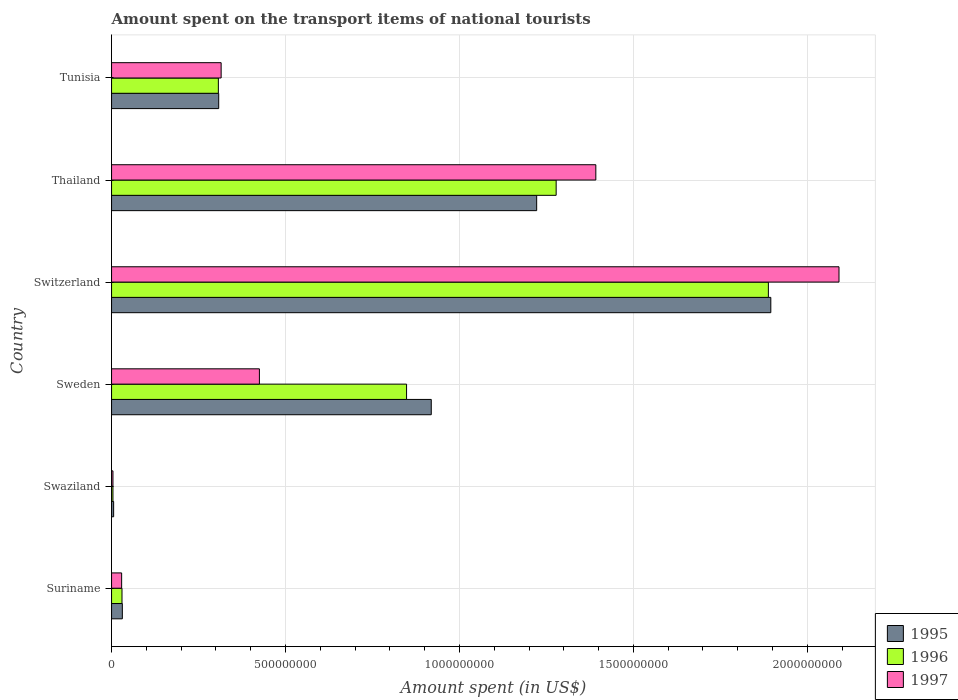How many different coloured bars are there?
Ensure brevity in your answer.  3. How many groups of bars are there?
Ensure brevity in your answer.  6. Are the number of bars per tick equal to the number of legend labels?
Offer a terse response. Yes. How many bars are there on the 2nd tick from the bottom?
Ensure brevity in your answer.  3. What is the amount spent on the transport items of national tourists in 1996 in Tunisia?
Make the answer very short. 3.07e+08. Across all countries, what is the maximum amount spent on the transport items of national tourists in 1996?
Provide a short and direct response. 1.89e+09. Across all countries, what is the minimum amount spent on the transport items of national tourists in 1995?
Your answer should be very brief. 6.00e+06. In which country was the amount spent on the transport items of national tourists in 1996 maximum?
Keep it short and to the point. Switzerland. In which country was the amount spent on the transport items of national tourists in 1995 minimum?
Your answer should be very brief. Swaziland. What is the total amount spent on the transport items of national tourists in 1996 in the graph?
Make the answer very short. 4.36e+09. What is the difference between the amount spent on the transport items of national tourists in 1996 in Switzerland and that in Tunisia?
Provide a succinct answer. 1.58e+09. What is the difference between the amount spent on the transport items of national tourists in 1996 in Tunisia and the amount spent on the transport items of national tourists in 1997 in Switzerland?
Offer a very short reply. -1.78e+09. What is the average amount spent on the transport items of national tourists in 1995 per country?
Offer a terse response. 7.30e+08. What is the difference between the amount spent on the transport items of national tourists in 1997 and amount spent on the transport items of national tourists in 1996 in Suriname?
Provide a short and direct response. -1.00e+06. What is the ratio of the amount spent on the transport items of national tourists in 1997 in Switzerland to that in Thailand?
Make the answer very short. 1.5. Is the amount spent on the transport items of national tourists in 1997 in Thailand less than that in Tunisia?
Provide a short and direct response. No. What is the difference between the highest and the second highest amount spent on the transport items of national tourists in 1997?
Provide a short and direct response. 6.99e+08. What is the difference between the highest and the lowest amount spent on the transport items of national tourists in 1995?
Provide a succinct answer. 1.89e+09. Is the sum of the amount spent on the transport items of national tourists in 1996 in Switzerland and Tunisia greater than the maximum amount spent on the transport items of national tourists in 1995 across all countries?
Your answer should be compact. Yes. What does the 3rd bar from the top in Switzerland represents?
Ensure brevity in your answer.  1995. Is it the case that in every country, the sum of the amount spent on the transport items of national tourists in 1995 and amount spent on the transport items of national tourists in 1997 is greater than the amount spent on the transport items of national tourists in 1996?
Provide a succinct answer. Yes. Are all the bars in the graph horizontal?
Give a very brief answer. Yes. How many countries are there in the graph?
Make the answer very short. 6. What is the difference between two consecutive major ticks on the X-axis?
Keep it short and to the point. 5.00e+08. Where does the legend appear in the graph?
Offer a very short reply. Bottom right. What is the title of the graph?
Your answer should be very brief. Amount spent on the transport items of national tourists. What is the label or title of the X-axis?
Your response must be concise. Amount spent (in US$). What is the label or title of the Y-axis?
Your answer should be compact. Country. What is the Amount spent (in US$) in 1995 in Suriname?
Offer a terse response. 3.10e+07. What is the Amount spent (in US$) in 1996 in Suriname?
Provide a succinct answer. 3.00e+07. What is the Amount spent (in US$) of 1997 in Suriname?
Your response must be concise. 2.90e+07. What is the Amount spent (in US$) of 1996 in Swaziland?
Make the answer very short. 4.00e+06. What is the Amount spent (in US$) in 1995 in Sweden?
Provide a succinct answer. 9.19e+08. What is the Amount spent (in US$) of 1996 in Sweden?
Offer a very short reply. 8.48e+08. What is the Amount spent (in US$) in 1997 in Sweden?
Make the answer very short. 4.25e+08. What is the Amount spent (in US$) of 1995 in Switzerland?
Your answer should be very brief. 1.90e+09. What is the Amount spent (in US$) in 1996 in Switzerland?
Offer a terse response. 1.89e+09. What is the Amount spent (in US$) of 1997 in Switzerland?
Ensure brevity in your answer.  2.09e+09. What is the Amount spent (in US$) of 1995 in Thailand?
Your answer should be very brief. 1.22e+09. What is the Amount spent (in US$) of 1996 in Thailand?
Keep it short and to the point. 1.28e+09. What is the Amount spent (in US$) in 1997 in Thailand?
Offer a very short reply. 1.39e+09. What is the Amount spent (in US$) in 1995 in Tunisia?
Your answer should be compact. 3.08e+08. What is the Amount spent (in US$) in 1996 in Tunisia?
Provide a short and direct response. 3.07e+08. What is the Amount spent (in US$) in 1997 in Tunisia?
Give a very brief answer. 3.15e+08. Across all countries, what is the maximum Amount spent (in US$) of 1995?
Your answer should be very brief. 1.90e+09. Across all countries, what is the maximum Amount spent (in US$) in 1996?
Your response must be concise. 1.89e+09. Across all countries, what is the maximum Amount spent (in US$) in 1997?
Your answer should be very brief. 2.09e+09. Across all countries, what is the minimum Amount spent (in US$) of 1997?
Provide a succinct answer. 4.00e+06. What is the total Amount spent (in US$) in 1995 in the graph?
Offer a very short reply. 4.38e+09. What is the total Amount spent (in US$) of 1996 in the graph?
Your answer should be compact. 4.36e+09. What is the total Amount spent (in US$) in 1997 in the graph?
Your response must be concise. 4.26e+09. What is the difference between the Amount spent (in US$) in 1995 in Suriname and that in Swaziland?
Ensure brevity in your answer.  2.50e+07. What is the difference between the Amount spent (in US$) of 1996 in Suriname and that in Swaziland?
Your response must be concise. 2.60e+07. What is the difference between the Amount spent (in US$) in 1997 in Suriname and that in Swaziland?
Your response must be concise. 2.50e+07. What is the difference between the Amount spent (in US$) in 1995 in Suriname and that in Sweden?
Provide a succinct answer. -8.88e+08. What is the difference between the Amount spent (in US$) of 1996 in Suriname and that in Sweden?
Make the answer very short. -8.18e+08. What is the difference between the Amount spent (in US$) in 1997 in Suriname and that in Sweden?
Offer a very short reply. -3.96e+08. What is the difference between the Amount spent (in US$) of 1995 in Suriname and that in Switzerland?
Ensure brevity in your answer.  -1.86e+09. What is the difference between the Amount spent (in US$) in 1996 in Suriname and that in Switzerland?
Offer a very short reply. -1.86e+09. What is the difference between the Amount spent (in US$) of 1997 in Suriname and that in Switzerland?
Ensure brevity in your answer.  -2.06e+09. What is the difference between the Amount spent (in US$) in 1995 in Suriname and that in Thailand?
Provide a short and direct response. -1.19e+09. What is the difference between the Amount spent (in US$) in 1996 in Suriname and that in Thailand?
Ensure brevity in your answer.  -1.25e+09. What is the difference between the Amount spent (in US$) of 1997 in Suriname and that in Thailand?
Make the answer very short. -1.36e+09. What is the difference between the Amount spent (in US$) of 1995 in Suriname and that in Tunisia?
Ensure brevity in your answer.  -2.77e+08. What is the difference between the Amount spent (in US$) of 1996 in Suriname and that in Tunisia?
Provide a short and direct response. -2.77e+08. What is the difference between the Amount spent (in US$) of 1997 in Suriname and that in Tunisia?
Offer a very short reply. -2.86e+08. What is the difference between the Amount spent (in US$) in 1995 in Swaziland and that in Sweden?
Provide a succinct answer. -9.13e+08. What is the difference between the Amount spent (in US$) in 1996 in Swaziland and that in Sweden?
Ensure brevity in your answer.  -8.44e+08. What is the difference between the Amount spent (in US$) of 1997 in Swaziland and that in Sweden?
Your response must be concise. -4.21e+08. What is the difference between the Amount spent (in US$) in 1995 in Swaziland and that in Switzerland?
Ensure brevity in your answer.  -1.89e+09. What is the difference between the Amount spent (in US$) of 1996 in Swaziland and that in Switzerland?
Offer a very short reply. -1.88e+09. What is the difference between the Amount spent (in US$) in 1997 in Swaziland and that in Switzerland?
Offer a very short reply. -2.09e+09. What is the difference between the Amount spent (in US$) in 1995 in Swaziland and that in Thailand?
Make the answer very short. -1.22e+09. What is the difference between the Amount spent (in US$) of 1996 in Swaziland and that in Thailand?
Provide a short and direct response. -1.27e+09. What is the difference between the Amount spent (in US$) of 1997 in Swaziland and that in Thailand?
Your answer should be very brief. -1.39e+09. What is the difference between the Amount spent (in US$) in 1995 in Swaziland and that in Tunisia?
Give a very brief answer. -3.02e+08. What is the difference between the Amount spent (in US$) of 1996 in Swaziland and that in Tunisia?
Offer a terse response. -3.03e+08. What is the difference between the Amount spent (in US$) of 1997 in Swaziland and that in Tunisia?
Offer a very short reply. -3.11e+08. What is the difference between the Amount spent (in US$) in 1995 in Sweden and that in Switzerland?
Provide a succinct answer. -9.76e+08. What is the difference between the Amount spent (in US$) of 1996 in Sweden and that in Switzerland?
Keep it short and to the point. -1.04e+09. What is the difference between the Amount spent (in US$) of 1997 in Sweden and that in Switzerland?
Give a very brief answer. -1.67e+09. What is the difference between the Amount spent (in US$) of 1995 in Sweden and that in Thailand?
Ensure brevity in your answer.  -3.03e+08. What is the difference between the Amount spent (in US$) in 1996 in Sweden and that in Thailand?
Your response must be concise. -4.30e+08. What is the difference between the Amount spent (in US$) of 1997 in Sweden and that in Thailand?
Offer a terse response. -9.67e+08. What is the difference between the Amount spent (in US$) of 1995 in Sweden and that in Tunisia?
Provide a short and direct response. 6.11e+08. What is the difference between the Amount spent (in US$) of 1996 in Sweden and that in Tunisia?
Keep it short and to the point. 5.41e+08. What is the difference between the Amount spent (in US$) in 1997 in Sweden and that in Tunisia?
Make the answer very short. 1.10e+08. What is the difference between the Amount spent (in US$) in 1995 in Switzerland and that in Thailand?
Ensure brevity in your answer.  6.73e+08. What is the difference between the Amount spent (in US$) of 1996 in Switzerland and that in Thailand?
Provide a succinct answer. 6.10e+08. What is the difference between the Amount spent (in US$) in 1997 in Switzerland and that in Thailand?
Provide a succinct answer. 6.99e+08. What is the difference between the Amount spent (in US$) of 1995 in Switzerland and that in Tunisia?
Provide a short and direct response. 1.59e+09. What is the difference between the Amount spent (in US$) in 1996 in Switzerland and that in Tunisia?
Provide a short and direct response. 1.58e+09. What is the difference between the Amount spent (in US$) in 1997 in Switzerland and that in Tunisia?
Your answer should be very brief. 1.78e+09. What is the difference between the Amount spent (in US$) of 1995 in Thailand and that in Tunisia?
Make the answer very short. 9.14e+08. What is the difference between the Amount spent (in US$) in 1996 in Thailand and that in Tunisia?
Give a very brief answer. 9.71e+08. What is the difference between the Amount spent (in US$) of 1997 in Thailand and that in Tunisia?
Make the answer very short. 1.08e+09. What is the difference between the Amount spent (in US$) in 1995 in Suriname and the Amount spent (in US$) in 1996 in Swaziland?
Give a very brief answer. 2.70e+07. What is the difference between the Amount spent (in US$) of 1995 in Suriname and the Amount spent (in US$) of 1997 in Swaziland?
Provide a short and direct response. 2.70e+07. What is the difference between the Amount spent (in US$) in 1996 in Suriname and the Amount spent (in US$) in 1997 in Swaziland?
Your answer should be very brief. 2.60e+07. What is the difference between the Amount spent (in US$) of 1995 in Suriname and the Amount spent (in US$) of 1996 in Sweden?
Offer a very short reply. -8.17e+08. What is the difference between the Amount spent (in US$) in 1995 in Suriname and the Amount spent (in US$) in 1997 in Sweden?
Your response must be concise. -3.94e+08. What is the difference between the Amount spent (in US$) of 1996 in Suriname and the Amount spent (in US$) of 1997 in Sweden?
Ensure brevity in your answer.  -3.95e+08. What is the difference between the Amount spent (in US$) in 1995 in Suriname and the Amount spent (in US$) in 1996 in Switzerland?
Your answer should be compact. -1.86e+09. What is the difference between the Amount spent (in US$) of 1995 in Suriname and the Amount spent (in US$) of 1997 in Switzerland?
Give a very brief answer. -2.06e+09. What is the difference between the Amount spent (in US$) of 1996 in Suriname and the Amount spent (in US$) of 1997 in Switzerland?
Keep it short and to the point. -2.06e+09. What is the difference between the Amount spent (in US$) in 1995 in Suriname and the Amount spent (in US$) in 1996 in Thailand?
Provide a succinct answer. -1.25e+09. What is the difference between the Amount spent (in US$) in 1995 in Suriname and the Amount spent (in US$) in 1997 in Thailand?
Give a very brief answer. -1.36e+09. What is the difference between the Amount spent (in US$) in 1996 in Suriname and the Amount spent (in US$) in 1997 in Thailand?
Offer a terse response. -1.36e+09. What is the difference between the Amount spent (in US$) in 1995 in Suriname and the Amount spent (in US$) in 1996 in Tunisia?
Your answer should be very brief. -2.76e+08. What is the difference between the Amount spent (in US$) in 1995 in Suriname and the Amount spent (in US$) in 1997 in Tunisia?
Your answer should be very brief. -2.84e+08. What is the difference between the Amount spent (in US$) of 1996 in Suriname and the Amount spent (in US$) of 1997 in Tunisia?
Keep it short and to the point. -2.85e+08. What is the difference between the Amount spent (in US$) of 1995 in Swaziland and the Amount spent (in US$) of 1996 in Sweden?
Keep it short and to the point. -8.42e+08. What is the difference between the Amount spent (in US$) of 1995 in Swaziland and the Amount spent (in US$) of 1997 in Sweden?
Make the answer very short. -4.19e+08. What is the difference between the Amount spent (in US$) of 1996 in Swaziland and the Amount spent (in US$) of 1997 in Sweden?
Your response must be concise. -4.21e+08. What is the difference between the Amount spent (in US$) of 1995 in Swaziland and the Amount spent (in US$) of 1996 in Switzerland?
Offer a terse response. -1.88e+09. What is the difference between the Amount spent (in US$) of 1995 in Swaziland and the Amount spent (in US$) of 1997 in Switzerland?
Provide a short and direct response. -2.08e+09. What is the difference between the Amount spent (in US$) in 1996 in Swaziland and the Amount spent (in US$) in 1997 in Switzerland?
Keep it short and to the point. -2.09e+09. What is the difference between the Amount spent (in US$) in 1995 in Swaziland and the Amount spent (in US$) in 1996 in Thailand?
Your answer should be compact. -1.27e+09. What is the difference between the Amount spent (in US$) in 1995 in Swaziland and the Amount spent (in US$) in 1997 in Thailand?
Provide a short and direct response. -1.39e+09. What is the difference between the Amount spent (in US$) of 1996 in Swaziland and the Amount spent (in US$) of 1997 in Thailand?
Your answer should be very brief. -1.39e+09. What is the difference between the Amount spent (in US$) in 1995 in Swaziland and the Amount spent (in US$) in 1996 in Tunisia?
Your answer should be compact. -3.01e+08. What is the difference between the Amount spent (in US$) in 1995 in Swaziland and the Amount spent (in US$) in 1997 in Tunisia?
Keep it short and to the point. -3.09e+08. What is the difference between the Amount spent (in US$) of 1996 in Swaziland and the Amount spent (in US$) of 1997 in Tunisia?
Give a very brief answer. -3.11e+08. What is the difference between the Amount spent (in US$) in 1995 in Sweden and the Amount spent (in US$) in 1996 in Switzerland?
Provide a short and direct response. -9.69e+08. What is the difference between the Amount spent (in US$) of 1995 in Sweden and the Amount spent (in US$) of 1997 in Switzerland?
Provide a short and direct response. -1.17e+09. What is the difference between the Amount spent (in US$) in 1996 in Sweden and the Amount spent (in US$) in 1997 in Switzerland?
Keep it short and to the point. -1.24e+09. What is the difference between the Amount spent (in US$) of 1995 in Sweden and the Amount spent (in US$) of 1996 in Thailand?
Offer a terse response. -3.59e+08. What is the difference between the Amount spent (in US$) of 1995 in Sweden and the Amount spent (in US$) of 1997 in Thailand?
Keep it short and to the point. -4.73e+08. What is the difference between the Amount spent (in US$) in 1996 in Sweden and the Amount spent (in US$) in 1997 in Thailand?
Provide a succinct answer. -5.44e+08. What is the difference between the Amount spent (in US$) in 1995 in Sweden and the Amount spent (in US$) in 1996 in Tunisia?
Provide a short and direct response. 6.12e+08. What is the difference between the Amount spent (in US$) of 1995 in Sweden and the Amount spent (in US$) of 1997 in Tunisia?
Give a very brief answer. 6.04e+08. What is the difference between the Amount spent (in US$) of 1996 in Sweden and the Amount spent (in US$) of 1997 in Tunisia?
Provide a succinct answer. 5.33e+08. What is the difference between the Amount spent (in US$) of 1995 in Switzerland and the Amount spent (in US$) of 1996 in Thailand?
Offer a terse response. 6.17e+08. What is the difference between the Amount spent (in US$) of 1995 in Switzerland and the Amount spent (in US$) of 1997 in Thailand?
Make the answer very short. 5.03e+08. What is the difference between the Amount spent (in US$) in 1996 in Switzerland and the Amount spent (in US$) in 1997 in Thailand?
Make the answer very short. 4.96e+08. What is the difference between the Amount spent (in US$) in 1995 in Switzerland and the Amount spent (in US$) in 1996 in Tunisia?
Provide a succinct answer. 1.59e+09. What is the difference between the Amount spent (in US$) in 1995 in Switzerland and the Amount spent (in US$) in 1997 in Tunisia?
Keep it short and to the point. 1.58e+09. What is the difference between the Amount spent (in US$) of 1996 in Switzerland and the Amount spent (in US$) of 1997 in Tunisia?
Your answer should be very brief. 1.57e+09. What is the difference between the Amount spent (in US$) in 1995 in Thailand and the Amount spent (in US$) in 1996 in Tunisia?
Ensure brevity in your answer.  9.15e+08. What is the difference between the Amount spent (in US$) in 1995 in Thailand and the Amount spent (in US$) in 1997 in Tunisia?
Offer a terse response. 9.07e+08. What is the difference between the Amount spent (in US$) of 1996 in Thailand and the Amount spent (in US$) of 1997 in Tunisia?
Your response must be concise. 9.63e+08. What is the average Amount spent (in US$) of 1995 per country?
Offer a very short reply. 7.30e+08. What is the average Amount spent (in US$) of 1996 per country?
Provide a short and direct response. 7.26e+08. What is the average Amount spent (in US$) in 1997 per country?
Your response must be concise. 7.09e+08. What is the difference between the Amount spent (in US$) of 1995 and Amount spent (in US$) of 1996 in Suriname?
Offer a very short reply. 1.00e+06. What is the difference between the Amount spent (in US$) of 1996 and Amount spent (in US$) of 1997 in Suriname?
Your answer should be compact. 1.00e+06. What is the difference between the Amount spent (in US$) in 1995 and Amount spent (in US$) in 1997 in Swaziland?
Ensure brevity in your answer.  2.00e+06. What is the difference between the Amount spent (in US$) in 1996 and Amount spent (in US$) in 1997 in Swaziland?
Offer a very short reply. 0. What is the difference between the Amount spent (in US$) of 1995 and Amount spent (in US$) of 1996 in Sweden?
Make the answer very short. 7.10e+07. What is the difference between the Amount spent (in US$) of 1995 and Amount spent (in US$) of 1997 in Sweden?
Your answer should be compact. 4.94e+08. What is the difference between the Amount spent (in US$) in 1996 and Amount spent (in US$) in 1997 in Sweden?
Your response must be concise. 4.23e+08. What is the difference between the Amount spent (in US$) of 1995 and Amount spent (in US$) of 1996 in Switzerland?
Offer a very short reply. 7.00e+06. What is the difference between the Amount spent (in US$) of 1995 and Amount spent (in US$) of 1997 in Switzerland?
Your answer should be compact. -1.96e+08. What is the difference between the Amount spent (in US$) of 1996 and Amount spent (in US$) of 1997 in Switzerland?
Your response must be concise. -2.03e+08. What is the difference between the Amount spent (in US$) in 1995 and Amount spent (in US$) in 1996 in Thailand?
Make the answer very short. -5.60e+07. What is the difference between the Amount spent (in US$) in 1995 and Amount spent (in US$) in 1997 in Thailand?
Your response must be concise. -1.70e+08. What is the difference between the Amount spent (in US$) in 1996 and Amount spent (in US$) in 1997 in Thailand?
Keep it short and to the point. -1.14e+08. What is the difference between the Amount spent (in US$) in 1995 and Amount spent (in US$) in 1996 in Tunisia?
Keep it short and to the point. 1.00e+06. What is the difference between the Amount spent (in US$) of 1995 and Amount spent (in US$) of 1997 in Tunisia?
Keep it short and to the point. -7.00e+06. What is the difference between the Amount spent (in US$) of 1996 and Amount spent (in US$) of 1997 in Tunisia?
Give a very brief answer. -8.00e+06. What is the ratio of the Amount spent (in US$) in 1995 in Suriname to that in Swaziland?
Offer a terse response. 5.17. What is the ratio of the Amount spent (in US$) in 1997 in Suriname to that in Swaziland?
Keep it short and to the point. 7.25. What is the ratio of the Amount spent (in US$) of 1995 in Suriname to that in Sweden?
Ensure brevity in your answer.  0.03. What is the ratio of the Amount spent (in US$) in 1996 in Suriname to that in Sweden?
Make the answer very short. 0.04. What is the ratio of the Amount spent (in US$) of 1997 in Suriname to that in Sweden?
Your answer should be very brief. 0.07. What is the ratio of the Amount spent (in US$) in 1995 in Suriname to that in Switzerland?
Your answer should be very brief. 0.02. What is the ratio of the Amount spent (in US$) of 1996 in Suriname to that in Switzerland?
Offer a very short reply. 0.02. What is the ratio of the Amount spent (in US$) in 1997 in Suriname to that in Switzerland?
Keep it short and to the point. 0.01. What is the ratio of the Amount spent (in US$) in 1995 in Suriname to that in Thailand?
Ensure brevity in your answer.  0.03. What is the ratio of the Amount spent (in US$) in 1996 in Suriname to that in Thailand?
Give a very brief answer. 0.02. What is the ratio of the Amount spent (in US$) in 1997 in Suriname to that in Thailand?
Your answer should be very brief. 0.02. What is the ratio of the Amount spent (in US$) in 1995 in Suriname to that in Tunisia?
Your response must be concise. 0.1. What is the ratio of the Amount spent (in US$) of 1996 in Suriname to that in Tunisia?
Provide a short and direct response. 0.1. What is the ratio of the Amount spent (in US$) of 1997 in Suriname to that in Tunisia?
Make the answer very short. 0.09. What is the ratio of the Amount spent (in US$) of 1995 in Swaziland to that in Sweden?
Give a very brief answer. 0.01. What is the ratio of the Amount spent (in US$) of 1996 in Swaziland to that in Sweden?
Your answer should be compact. 0. What is the ratio of the Amount spent (in US$) in 1997 in Swaziland to that in Sweden?
Your response must be concise. 0.01. What is the ratio of the Amount spent (in US$) of 1995 in Swaziland to that in Switzerland?
Your response must be concise. 0. What is the ratio of the Amount spent (in US$) in 1996 in Swaziland to that in Switzerland?
Make the answer very short. 0. What is the ratio of the Amount spent (in US$) of 1997 in Swaziland to that in Switzerland?
Provide a succinct answer. 0. What is the ratio of the Amount spent (in US$) of 1995 in Swaziland to that in Thailand?
Your answer should be compact. 0. What is the ratio of the Amount spent (in US$) in 1996 in Swaziland to that in Thailand?
Provide a short and direct response. 0. What is the ratio of the Amount spent (in US$) of 1997 in Swaziland to that in Thailand?
Keep it short and to the point. 0. What is the ratio of the Amount spent (in US$) in 1995 in Swaziland to that in Tunisia?
Your answer should be very brief. 0.02. What is the ratio of the Amount spent (in US$) of 1996 in Swaziland to that in Tunisia?
Offer a terse response. 0.01. What is the ratio of the Amount spent (in US$) in 1997 in Swaziland to that in Tunisia?
Give a very brief answer. 0.01. What is the ratio of the Amount spent (in US$) of 1995 in Sweden to that in Switzerland?
Offer a terse response. 0.48. What is the ratio of the Amount spent (in US$) in 1996 in Sweden to that in Switzerland?
Offer a very short reply. 0.45. What is the ratio of the Amount spent (in US$) of 1997 in Sweden to that in Switzerland?
Provide a succinct answer. 0.2. What is the ratio of the Amount spent (in US$) of 1995 in Sweden to that in Thailand?
Provide a short and direct response. 0.75. What is the ratio of the Amount spent (in US$) in 1996 in Sweden to that in Thailand?
Your answer should be very brief. 0.66. What is the ratio of the Amount spent (in US$) of 1997 in Sweden to that in Thailand?
Provide a short and direct response. 0.31. What is the ratio of the Amount spent (in US$) of 1995 in Sweden to that in Tunisia?
Your answer should be very brief. 2.98. What is the ratio of the Amount spent (in US$) in 1996 in Sweden to that in Tunisia?
Provide a succinct answer. 2.76. What is the ratio of the Amount spent (in US$) of 1997 in Sweden to that in Tunisia?
Offer a very short reply. 1.35. What is the ratio of the Amount spent (in US$) of 1995 in Switzerland to that in Thailand?
Ensure brevity in your answer.  1.55. What is the ratio of the Amount spent (in US$) in 1996 in Switzerland to that in Thailand?
Keep it short and to the point. 1.48. What is the ratio of the Amount spent (in US$) in 1997 in Switzerland to that in Thailand?
Your answer should be compact. 1.5. What is the ratio of the Amount spent (in US$) of 1995 in Switzerland to that in Tunisia?
Ensure brevity in your answer.  6.15. What is the ratio of the Amount spent (in US$) in 1996 in Switzerland to that in Tunisia?
Provide a short and direct response. 6.15. What is the ratio of the Amount spent (in US$) in 1997 in Switzerland to that in Tunisia?
Make the answer very short. 6.64. What is the ratio of the Amount spent (in US$) in 1995 in Thailand to that in Tunisia?
Give a very brief answer. 3.97. What is the ratio of the Amount spent (in US$) of 1996 in Thailand to that in Tunisia?
Ensure brevity in your answer.  4.16. What is the ratio of the Amount spent (in US$) in 1997 in Thailand to that in Tunisia?
Keep it short and to the point. 4.42. What is the difference between the highest and the second highest Amount spent (in US$) in 1995?
Your answer should be very brief. 6.73e+08. What is the difference between the highest and the second highest Amount spent (in US$) in 1996?
Your answer should be very brief. 6.10e+08. What is the difference between the highest and the second highest Amount spent (in US$) in 1997?
Offer a very short reply. 6.99e+08. What is the difference between the highest and the lowest Amount spent (in US$) in 1995?
Your answer should be very brief. 1.89e+09. What is the difference between the highest and the lowest Amount spent (in US$) in 1996?
Your response must be concise. 1.88e+09. What is the difference between the highest and the lowest Amount spent (in US$) in 1997?
Ensure brevity in your answer.  2.09e+09. 